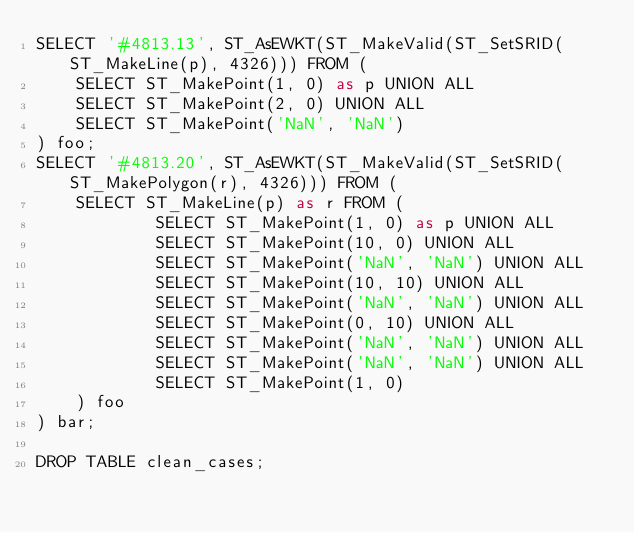Convert code to text. <code><loc_0><loc_0><loc_500><loc_500><_SQL_>SELECT '#4813.13', ST_AsEWKT(ST_MakeValid(ST_SetSRID(ST_MakeLine(p), 4326))) FROM (
	SELECT ST_MakePoint(1, 0) as p UNION ALL
	SELECT ST_MakePoint(2, 0) UNION ALL
	SELECT ST_MakePoint('NaN', 'NaN')
) foo;
SELECT '#4813.20', ST_AsEWKT(ST_MakeValid(ST_SetSRID(ST_MakePolygon(r), 4326))) FROM (
	SELECT ST_MakeLine(p) as r FROM (
			SELECT ST_MakePoint(1, 0) as p UNION ALL
			SELECT ST_MakePoint(10, 0) UNION ALL
			SELECT ST_MakePoint('NaN', 'NaN') UNION ALL
			SELECT ST_MakePoint(10, 10) UNION ALL
			SELECT ST_MakePoint('NaN', 'NaN') UNION ALL
			SELECT ST_MakePoint(0, 10) UNION ALL
			SELECT ST_MakePoint('NaN', 'NaN') UNION ALL
			SELECT ST_MakePoint('NaN', 'NaN') UNION ALL
			SELECT ST_MakePoint(1, 0)
	) foo
) bar;

DROP TABLE clean_cases;
</code> 